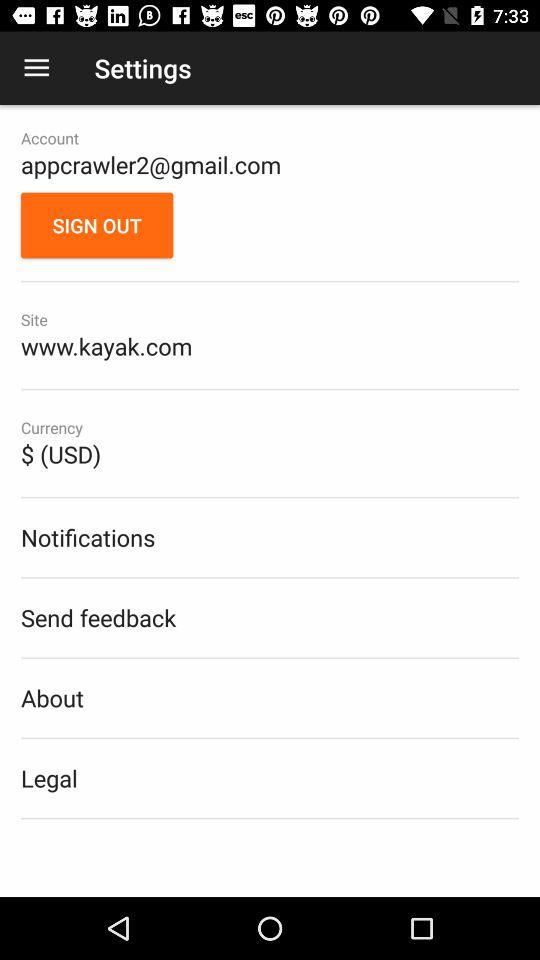What email address is used for an account? The email address used is "appcrawler2@gmail.com". 